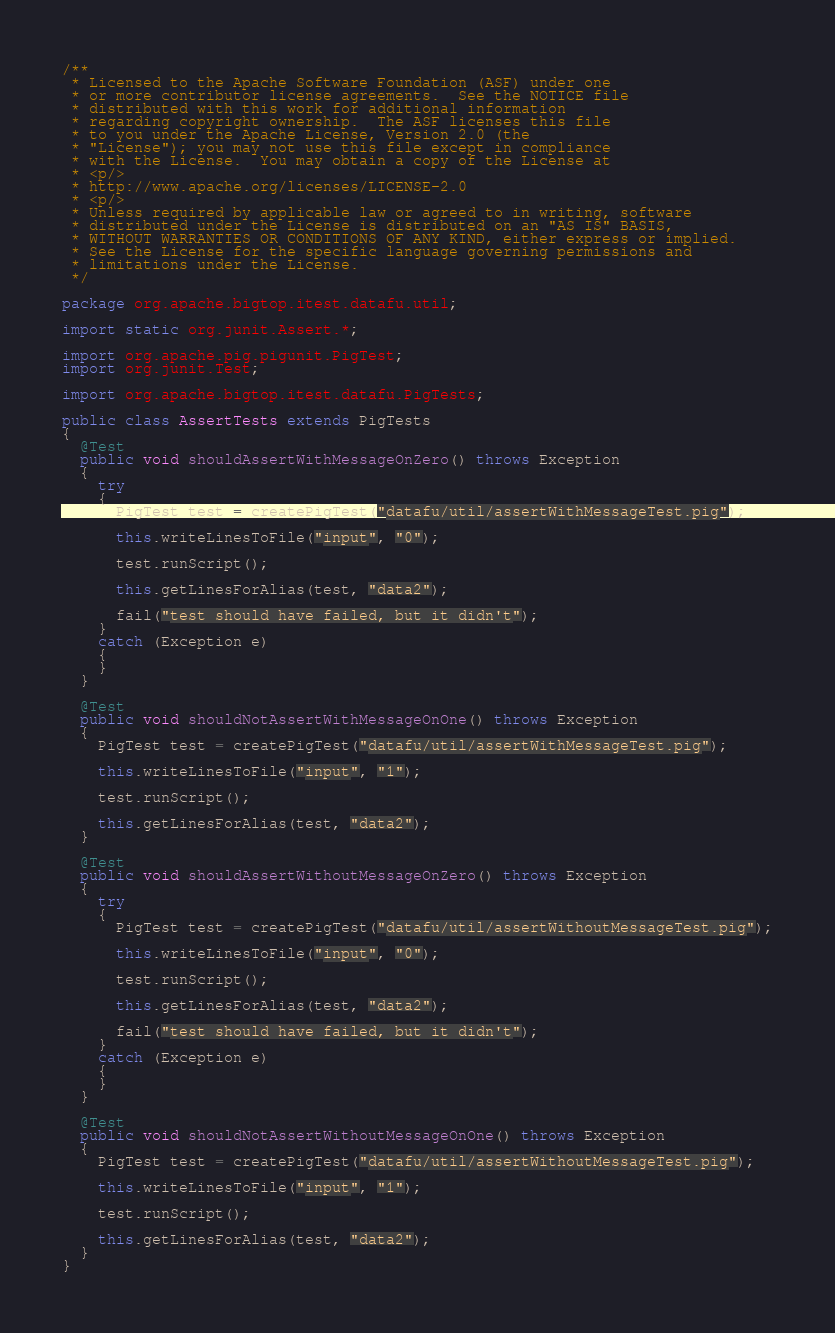Convert code to text. <code><loc_0><loc_0><loc_500><loc_500><_Java_>/**
 * Licensed to the Apache Software Foundation (ASF) under one
 * or more contributor license agreements.  See the NOTICE file
 * distributed with this work for additional information
 * regarding copyright ownership.  The ASF licenses this file
 * to you under the Apache License, Version 2.0 (the
 * "License"); you may not use this file except in compliance
 * with the License.  You may obtain a copy of the License at
 * <p/>
 * http://www.apache.org/licenses/LICENSE-2.0
 * <p/>
 * Unless required by applicable law or agreed to in writing, software
 * distributed under the License is distributed on an "AS IS" BASIS,
 * WITHOUT WARRANTIES OR CONDITIONS OF ANY KIND, either express or implied.
 * See the License for the specific language governing permissions and
 * limitations under the License.
 */

package org.apache.bigtop.itest.datafu.util;

import static org.junit.Assert.*;

import org.apache.pig.pigunit.PigTest;
import org.junit.Test;

import org.apache.bigtop.itest.datafu.PigTests;

public class AssertTests extends PigTests
{
  @Test
  public void shouldAssertWithMessageOnZero() throws Exception
  {
    try
    {
      PigTest test = createPigTest("datafu/util/assertWithMessageTest.pig");
      
      this.writeLinesToFile("input", "0");
      
      test.runScript();
      
      this.getLinesForAlias(test, "data2");
      
      fail("test should have failed, but it didn't");
    }
    catch (Exception e)
    {
    }
  }
  
  @Test
  public void shouldNotAssertWithMessageOnOne() throws Exception
  {
    PigTest test = createPigTest("datafu/util/assertWithMessageTest.pig");
    
    this.writeLinesToFile("input", "1");
    
    test.runScript();
    
    this.getLinesForAlias(test, "data2");
  }
  
  @Test
  public void shouldAssertWithoutMessageOnZero() throws Exception
  {
    try
    {
      PigTest test = createPigTest("datafu/util/assertWithoutMessageTest.pig");
      
      this.writeLinesToFile("input", "0");
      
      test.runScript();
      
      this.getLinesForAlias(test, "data2");
      
      fail("test should have failed, but it didn't");
    }
    catch (Exception e)
    {
    }
  }
  
  @Test
  public void shouldNotAssertWithoutMessageOnOne() throws Exception
  {
    PigTest test = createPigTest("datafu/util/assertWithoutMessageTest.pig");
    
    this.writeLinesToFile("input", "1");
    
    test.runScript();
    
    this.getLinesForAlias(test, "data2");
  }
}
</code> 